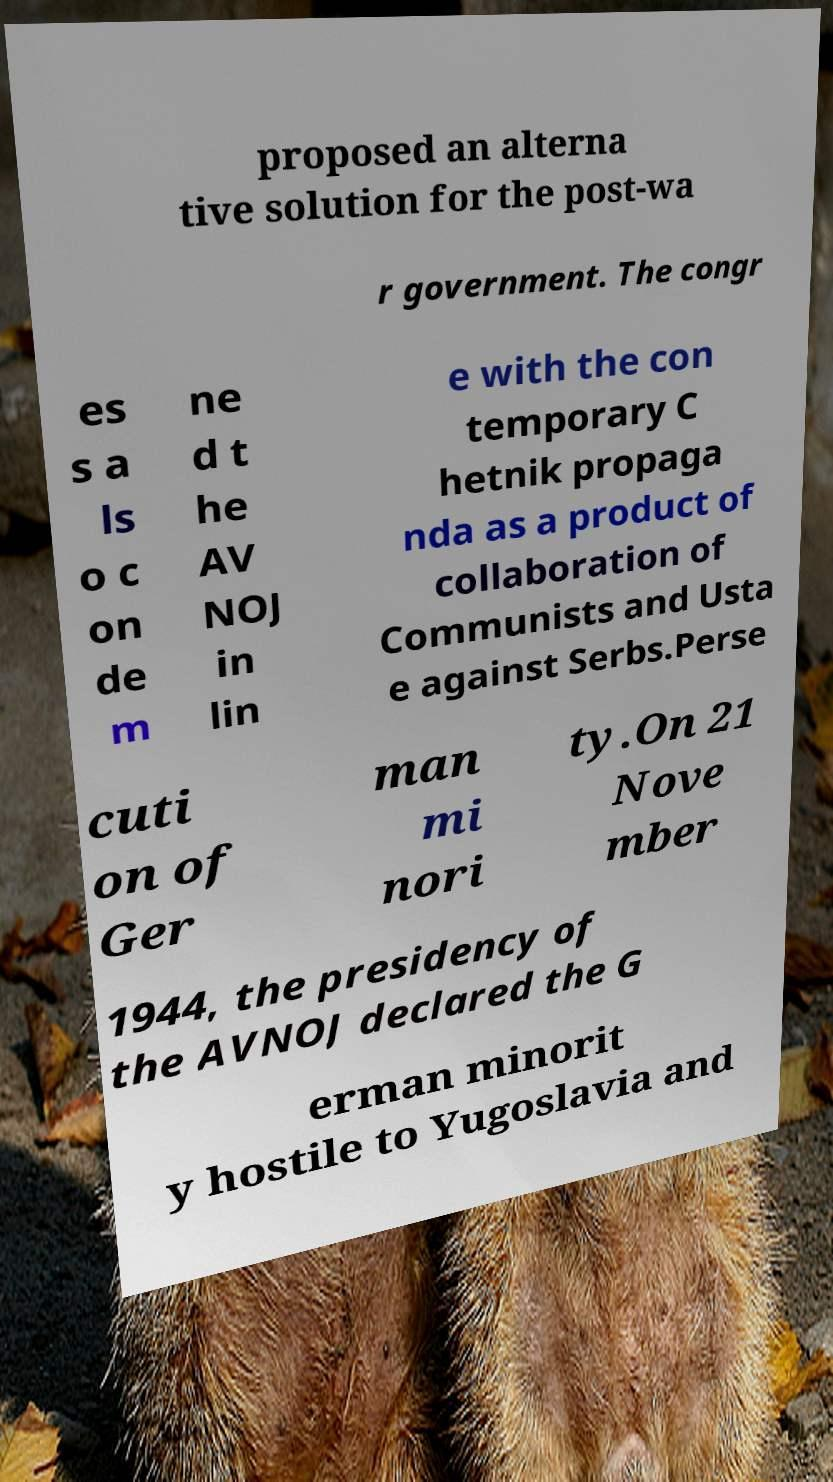Can you accurately transcribe the text from the provided image for me? proposed an alterna tive solution for the post-wa r government. The congr es s a ls o c on de m ne d t he AV NOJ in lin e with the con temporary C hetnik propaga nda as a product of collaboration of Communists and Usta e against Serbs.Perse cuti on of Ger man mi nori ty.On 21 Nove mber 1944, the presidency of the AVNOJ declared the G erman minorit y hostile to Yugoslavia and 